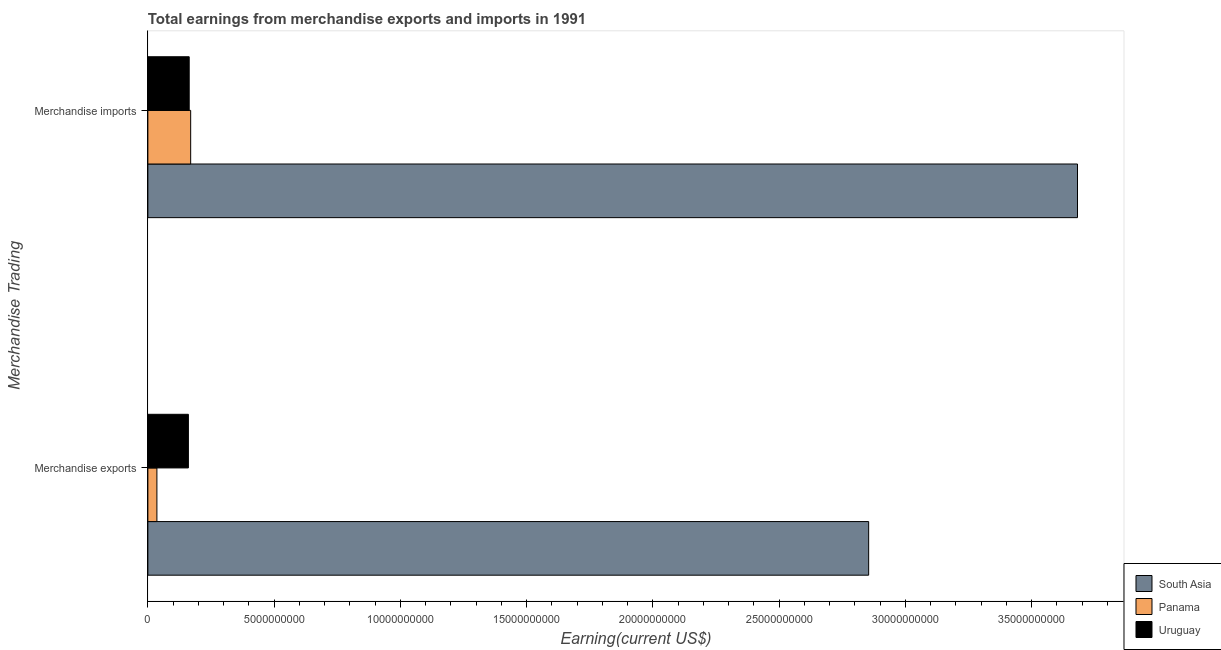Are the number of bars per tick equal to the number of legend labels?
Give a very brief answer. Yes. What is the earnings from merchandise imports in South Asia?
Offer a very short reply. 3.68e+1. Across all countries, what is the maximum earnings from merchandise imports?
Make the answer very short. 3.68e+1. Across all countries, what is the minimum earnings from merchandise exports?
Your response must be concise. 3.58e+08. In which country was the earnings from merchandise exports maximum?
Offer a very short reply. South Asia. In which country was the earnings from merchandise imports minimum?
Ensure brevity in your answer.  Uruguay. What is the total earnings from merchandise exports in the graph?
Offer a very short reply. 3.05e+1. What is the difference between the earnings from merchandise exports in Panama and that in Uruguay?
Provide a short and direct response. -1.25e+09. What is the difference between the earnings from merchandise exports in Panama and the earnings from merchandise imports in South Asia?
Make the answer very short. -3.65e+1. What is the average earnings from merchandise imports per country?
Make the answer very short. 1.34e+1. What is the difference between the earnings from merchandise exports and earnings from merchandise imports in South Asia?
Your response must be concise. -8.27e+09. What is the ratio of the earnings from merchandise imports in Panama to that in Uruguay?
Provide a short and direct response. 1.04. What does the 1st bar from the top in Merchandise exports represents?
Offer a very short reply. Uruguay. What does the 2nd bar from the bottom in Merchandise imports represents?
Make the answer very short. Panama. How many bars are there?
Keep it short and to the point. 6. Are all the bars in the graph horizontal?
Your answer should be compact. Yes. Are the values on the major ticks of X-axis written in scientific E-notation?
Keep it short and to the point. No. Does the graph contain any zero values?
Offer a terse response. No. Does the graph contain grids?
Give a very brief answer. No. Where does the legend appear in the graph?
Ensure brevity in your answer.  Bottom right. How many legend labels are there?
Your response must be concise. 3. How are the legend labels stacked?
Give a very brief answer. Vertical. What is the title of the graph?
Offer a terse response. Total earnings from merchandise exports and imports in 1991. Does "OECD members" appear as one of the legend labels in the graph?
Your answer should be very brief. No. What is the label or title of the X-axis?
Offer a very short reply. Earning(current US$). What is the label or title of the Y-axis?
Provide a short and direct response. Merchandise Trading. What is the Earning(current US$) of South Asia in Merchandise exports?
Offer a very short reply. 2.85e+1. What is the Earning(current US$) in Panama in Merchandise exports?
Give a very brief answer. 3.58e+08. What is the Earning(current US$) in Uruguay in Merchandise exports?
Offer a very short reply. 1.60e+09. What is the Earning(current US$) of South Asia in Merchandise imports?
Offer a terse response. 3.68e+1. What is the Earning(current US$) in Panama in Merchandise imports?
Your answer should be very brief. 1.70e+09. What is the Earning(current US$) in Uruguay in Merchandise imports?
Make the answer very short. 1.64e+09. Across all Merchandise Trading, what is the maximum Earning(current US$) of South Asia?
Your answer should be compact. 3.68e+1. Across all Merchandise Trading, what is the maximum Earning(current US$) of Panama?
Give a very brief answer. 1.70e+09. Across all Merchandise Trading, what is the maximum Earning(current US$) of Uruguay?
Make the answer very short. 1.64e+09. Across all Merchandise Trading, what is the minimum Earning(current US$) of South Asia?
Ensure brevity in your answer.  2.85e+1. Across all Merchandise Trading, what is the minimum Earning(current US$) of Panama?
Your answer should be compact. 3.58e+08. Across all Merchandise Trading, what is the minimum Earning(current US$) in Uruguay?
Ensure brevity in your answer.  1.60e+09. What is the total Earning(current US$) of South Asia in the graph?
Provide a short and direct response. 6.54e+1. What is the total Earning(current US$) of Panama in the graph?
Provide a short and direct response. 2.05e+09. What is the total Earning(current US$) in Uruguay in the graph?
Your response must be concise. 3.24e+09. What is the difference between the Earning(current US$) of South Asia in Merchandise exports and that in Merchandise imports?
Ensure brevity in your answer.  -8.27e+09. What is the difference between the Earning(current US$) in Panama in Merchandise exports and that in Merchandise imports?
Give a very brief answer. -1.34e+09. What is the difference between the Earning(current US$) of Uruguay in Merchandise exports and that in Merchandise imports?
Keep it short and to the point. -3.20e+07. What is the difference between the Earning(current US$) of South Asia in Merchandise exports and the Earning(current US$) of Panama in Merchandise imports?
Your answer should be compact. 2.69e+1. What is the difference between the Earning(current US$) in South Asia in Merchandise exports and the Earning(current US$) in Uruguay in Merchandise imports?
Ensure brevity in your answer.  2.69e+1. What is the difference between the Earning(current US$) of Panama in Merchandise exports and the Earning(current US$) of Uruguay in Merchandise imports?
Offer a terse response. -1.28e+09. What is the average Earning(current US$) in South Asia per Merchandise Trading?
Give a very brief answer. 3.27e+1. What is the average Earning(current US$) of Panama per Merchandise Trading?
Your response must be concise. 1.03e+09. What is the average Earning(current US$) in Uruguay per Merchandise Trading?
Offer a very short reply. 1.62e+09. What is the difference between the Earning(current US$) in South Asia and Earning(current US$) in Panama in Merchandise exports?
Give a very brief answer. 2.82e+1. What is the difference between the Earning(current US$) of South Asia and Earning(current US$) of Uruguay in Merchandise exports?
Keep it short and to the point. 2.69e+1. What is the difference between the Earning(current US$) of Panama and Earning(current US$) of Uruguay in Merchandise exports?
Keep it short and to the point. -1.25e+09. What is the difference between the Earning(current US$) of South Asia and Earning(current US$) of Panama in Merchandise imports?
Your answer should be very brief. 3.51e+1. What is the difference between the Earning(current US$) in South Asia and Earning(current US$) in Uruguay in Merchandise imports?
Make the answer very short. 3.52e+1. What is the difference between the Earning(current US$) of Panama and Earning(current US$) of Uruguay in Merchandise imports?
Your answer should be very brief. 5.80e+07. What is the ratio of the Earning(current US$) of South Asia in Merchandise exports to that in Merchandise imports?
Keep it short and to the point. 0.78. What is the ratio of the Earning(current US$) in Panama in Merchandise exports to that in Merchandise imports?
Make the answer very short. 0.21. What is the ratio of the Earning(current US$) in Uruguay in Merchandise exports to that in Merchandise imports?
Keep it short and to the point. 0.98. What is the difference between the highest and the second highest Earning(current US$) of South Asia?
Provide a short and direct response. 8.27e+09. What is the difference between the highest and the second highest Earning(current US$) in Panama?
Your answer should be very brief. 1.34e+09. What is the difference between the highest and the second highest Earning(current US$) in Uruguay?
Ensure brevity in your answer.  3.20e+07. What is the difference between the highest and the lowest Earning(current US$) in South Asia?
Your answer should be very brief. 8.27e+09. What is the difference between the highest and the lowest Earning(current US$) in Panama?
Provide a short and direct response. 1.34e+09. What is the difference between the highest and the lowest Earning(current US$) of Uruguay?
Make the answer very short. 3.20e+07. 